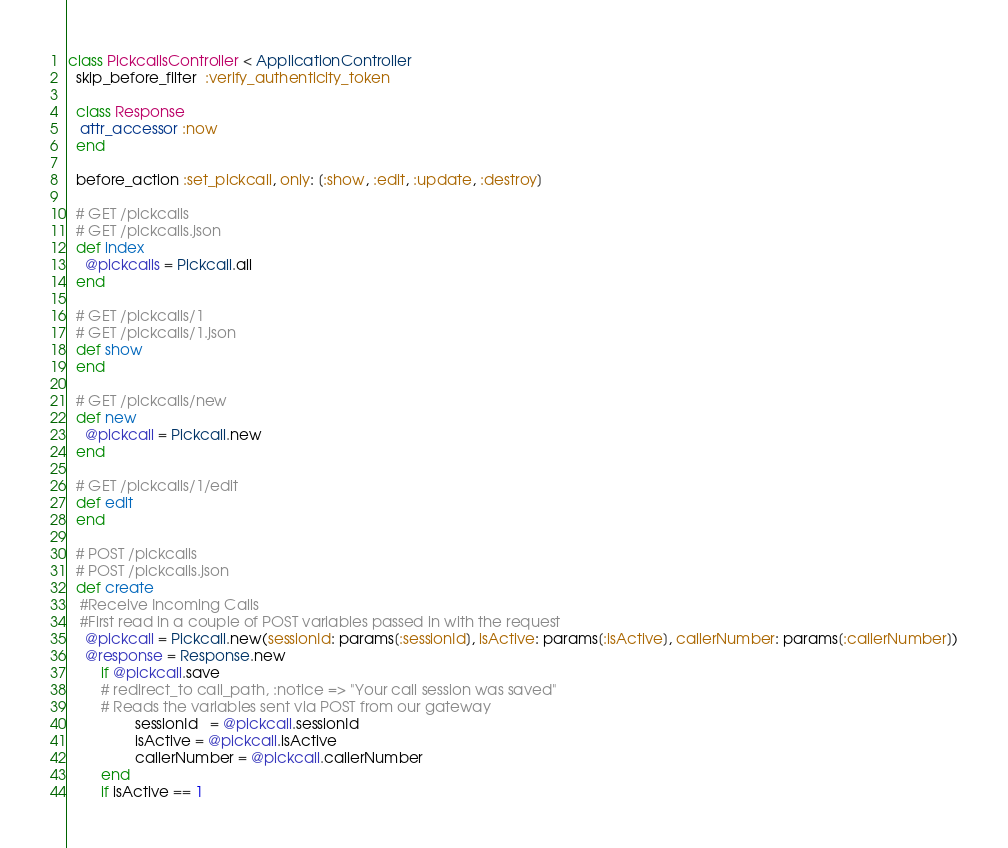<code> <loc_0><loc_0><loc_500><loc_500><_Ruby_>class PickcallsController < ApplicationController
  skip_before_filter  :verify_authenticity_token

  class Response
   attr_accessor :now
  end

  before_action :set_pickcall, only: [:show, :edit, :update, :destroy]

  # GET /pickcalls
  # GET /pickcalls.json
  def index
    @pickcalls = Pickcall.all
  end

  # GET /pickcalls/1
  # GET /pickcalls/1.json
  def show
  end

  # GET /pickcalls/new
  def new
    @pickcall = Pickcall.new
  end

  # GET /pickcalls/1/edit
  def edit
  end

  # POST /pickcalls
  # POST /pickcalls.json
  def create
   #Receive Incoming Calls 
   #First read in a couple of POST variables passed in with the request
    @pickcall = Pickcall.new(sessionId: params[:sessionId], isActive: params[:isActive], callerNumber: params[:callerNumber])
    @response = Response.new
        if @pickcall.save
        # redirect_to call_path, :notice => "Your call session was saved"
        # Reads the variables sent via POST from our gateway
                sessionId   = @pickcall.sessionId
                isActive = @pickcall.isActive
                callerNumber = @pickcall.callerNumber
        end
        if isActive == 1</code> 